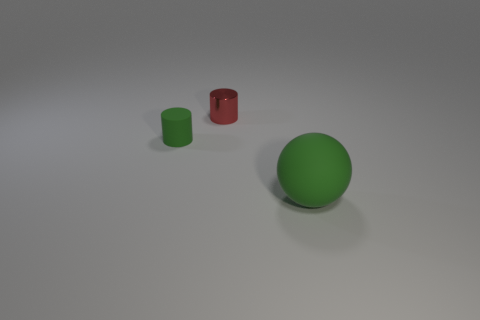Add 2 big blue shiny spheres. How many objects exist? 5 Subtract all spheres. How many objects are left? 2 Add 2 brown rubber spheres. How many brown rubber spheres exist? 2 Subtract 0 brown blocks. How many objects are left? 3 Subtract all green matte objects. Subtract all small green matte cylinders. How many objects are left? 0 Add 1 metal objects. How many metal objects are left? 2 